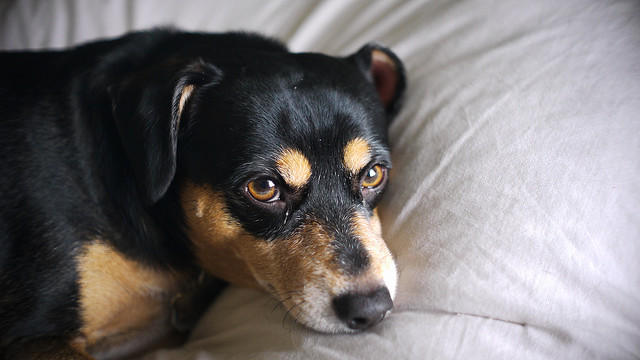<image>What is the breed of dog? I am not sure about the breed of the dog. It could be a mixed breed, beagle, rottweiler, boxer or doberman. What is the breed of dog? I am not sure what breed of dog it is. It can be seen as mixed breed chihuahua, mixed, beagle, rottweiler, black and tan, boxer, or doberman. 